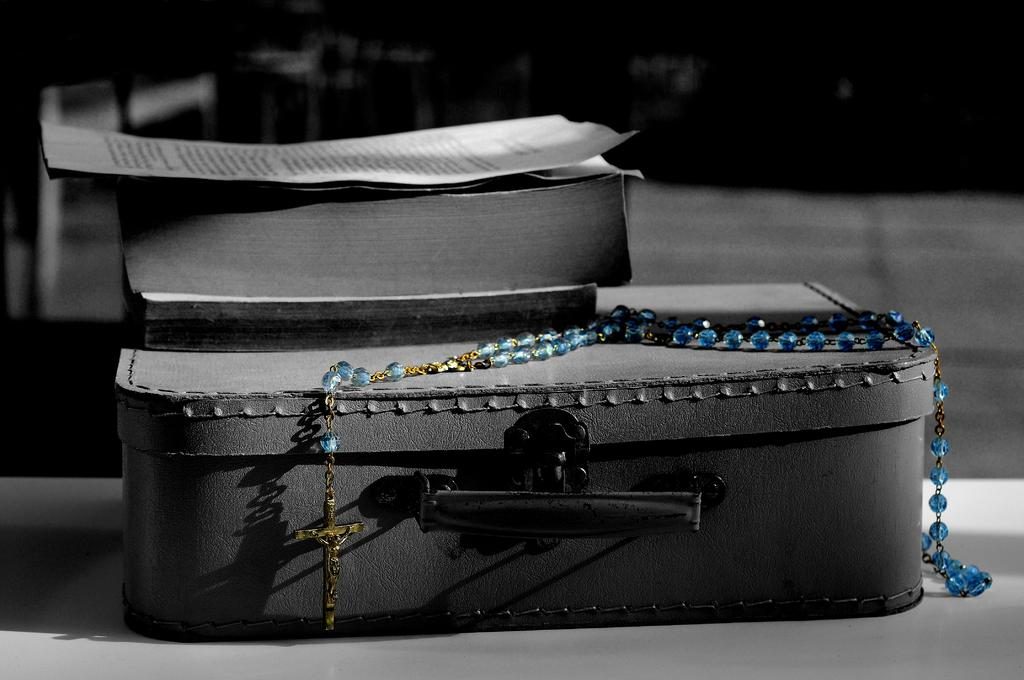What is the color scheme of the image? The image is black and white. What object can be seen in the image? There is a box in the image. What religious symbol is present in the image? There is a chain with a holy cross in the image. What religious text is visible in the image? There is a holy bible in the image. What is placed on top of the holy bible? There is a paper on the holy bible. How does the stick help to increase the pest population in the image? There is no stick or pest mentioned in the image; it features a box, a chain with a holy cross, a holy bible, and a paper. 